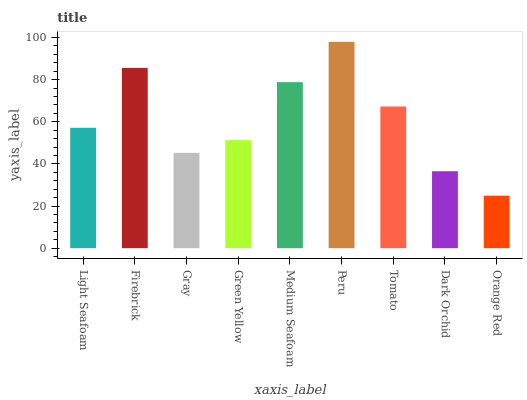Is Firebrick the minimum?
Answer yes or no. No. Is Firebrick the maximum?
Answer yes or no. No. Is Firebrick greater than Light Seafoam?
Answer yes or no. Yes. Is Light Seafoam less than Firebrick?
Answer yes or no. Yes. Is Light Seafoam greater than Firebrick?
Answer yes or no. No. Is Firebrick less than Light Seafoam?
Answer yes or no. No. Is Light Seafoam the high median?
Answer yes or no. Yes. Is Light Seafoam the low median?
Answer yes or no. Yes. Is Gray the high median?
Answer yes or no. No. Is Green Yellow the low median?
Answer yes or no. No. 